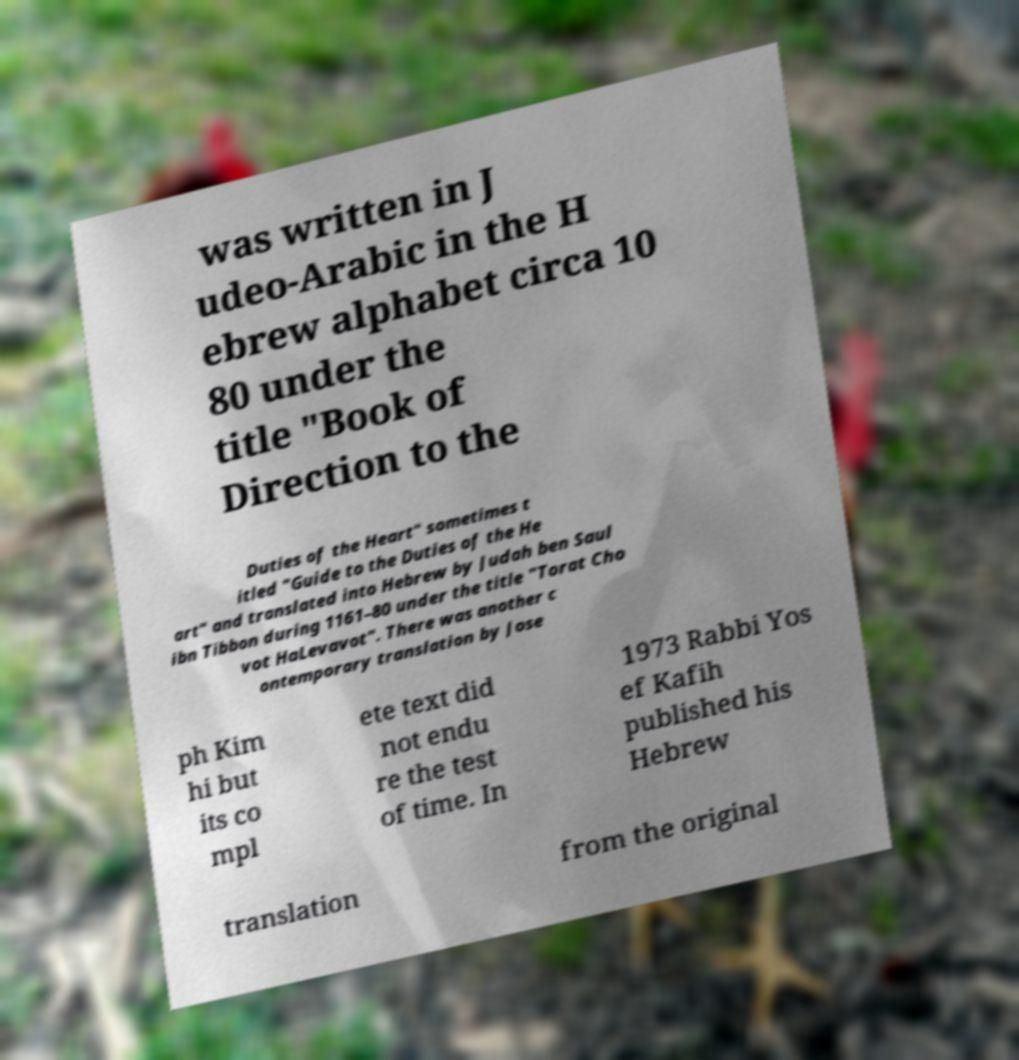Can you accurately transcribe the text from the provided image for me? was written in J udeo-Arabic in the H ebrew alphabet circa 10 80 under the title "Book of Direction to the Duties of the Heart" sometimes t itled "Guide to the Duties of the He art" and translated into Hebrew by Judah ben Saul ibn Tibbon during 1161–80 under the title "Torat Cho vot HaLevavot". There was another c ontemporary translation by Jose ph Kim hi but its co mpl ete text did not endu re the test of time. In 1973 Rabbi Yos ef Kafih published his Hebrew translation from the original 